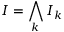Convert formula to latex. <formula><loc_0><loc_0><loc_500><loc_500>I = \bigwedge _ { k } I _ { k }</formula> 